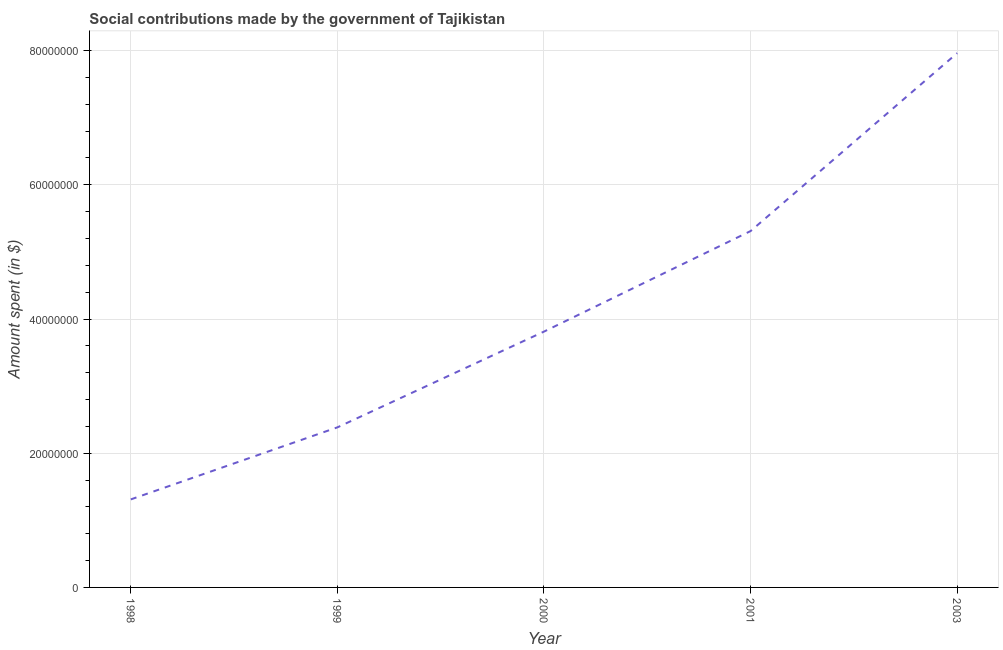What is the amount spent in making social contributions in 1999?
Keep it short and to the point. 2.39e+07. Across all years, what is the maximum amount spent in making social contributions?
Your response must be concise. 7.96e+07. Across all years, what is the minimum amount spent in making social contributions?
Your answer should be very brief. 1.31e+07. What is the sum of the amount spent in making social contributions?
Offer a terse response. 2.08e+08. What is the difference between the amount spent in making social contributions in 1998 and 2003?
Offer a terse response. -6.65e+07. What is the average amount spent in making social contributions per year?
Your answer should be very brief. 4.16e+07. What is the median amount spent in making social contributions?
Make the answer very short. 3.81e+07. Do a majority of the years between 2001 and 2003 (inclusive) have amount spent in making social contributions greater than 52000000 $?
Provide a succinct answer. Yes. What is the ratio of the amount spent in making social contributions in 1999 to that in 2000?
Keep it short and to the point. 0.63. Is the amount spent in making social contributions in 1998 less than that in 2003?
Your answer should be compact. Yes. What is the difference between the highest and the second highest amount spent in making social contributions?
Ensure brevity in your answer.  2.65e+07. What is the difference between the highest and the lowest amount spent in making social contributions?
Give a very brief answer. 6.65e+07. Does the amount spent in making social contributions monotonically increase over the years?
Your answer should be very brief. Yes. How many years are there in the graph?
Offer a terse response. 5. What is the difference between two consecutive major ticks on the Y-axis?
Ensure brevity in your answer.  2.00e+07. Are the values on the major ticks of Y-axis written in scientific E-notation?
Provide a succinct answer. No. Does the graph contain any zero values?
Offer a terse response. No. What is the title of the graph?
Make the answer very short. Social contributions made by the government of Tajikistan. What is the label or title of the X-axis?
Ensure brevity in your answer.  Year. What is the label or title of the Y-axis?
Your answer should be very brief. Amount spent (in $). What is the Amount spent (in $) in 1998?
Keep it short and to the point. 1.31e+07. What is the Amount spent (in $) of 1999?
Your answer should be very brief. 2.39e+07. What is the Amount spent (in $) of 2000?
Your response must be concise. 3.81e+07. What is the Amount spent (in $) in 2001?
Ensure brevity in your answer.  5.31e+07. What is the Amount spent (in $) in 2003?
Provide a succinct answer. 7.96e+07. What is the difference between the Amount spent (in $) in 1998 and 1999?
Ensure brevity in your answer.  -1.07e+07. What is the difference between the Amount spent (in $) in 1998 and 2000?
Ensure brevity in your answer.  -2.50e+07. What is the difference between the Amount spent (in $) in 1998 and 2001?
Your response must be concise. -4.00e+07. What is the difference between the Amount spent (in $) in 1998 and 2003?
Keep it short and to the point. -6.65e+07. What is the difference between the Amount spent (in $) in 1999 and 2000?
Provide a succinct answer. -1.43e+07. What is the difference between the Amount spent (in $) in 1999 and 2001?
Provide a succinct answer. -2.93e+07. What is the difference between the Amount spent (in $) in 1999 and 2003?
Make the answer very short. -5.58e+07. What is the difference between the Amount spent (in $) in 2000 and 2001?
Provide a short and direct response. -1.50e+07. What is the difference between the Amount spent (in $) in 2000 and 2003?
Offer a terse response. -4.15e+07. What is the difference between the Amount spent (in $) in 2001 and 2003?
Make the answer very short. -2.65e+07. What is the ratio of the Amount spent (in $) in 1998 to that in 1999?
Offer a terse response. 0.55. What is the ratio of the Amount spent (in $) in 1998 to that in 2000?
Offer a very short reply. 0.34. What is the ratio of the Amount spent (in $) in 1998 to that in 2001?
Offer a terse response. 0.25. What is the ratio of the Amount spent (in $) in 1998 to that in 2003?
Your response must be concise. 0.17. What is the ratio of the Amount spent (in $) in 1999 to that in 2000?
Ensure brevity in your answer.  0.63. What is the ratio of the Amount spent (in $) in 1999 to that in 2001?
Your answer should be very brief. 0.45. What is the ratio of the Amount spent (in $) in 2000 to that in 2001?
Offer a terse response. 0.72. What is the ratio of the Amount spent (in $) in 2000 to that in 2003?
Your answer should be compact. 0.48. What is the ratio of the Amount spent (in $) in 2001 to that in 2003?
Give a very brief answer. 0.67. 